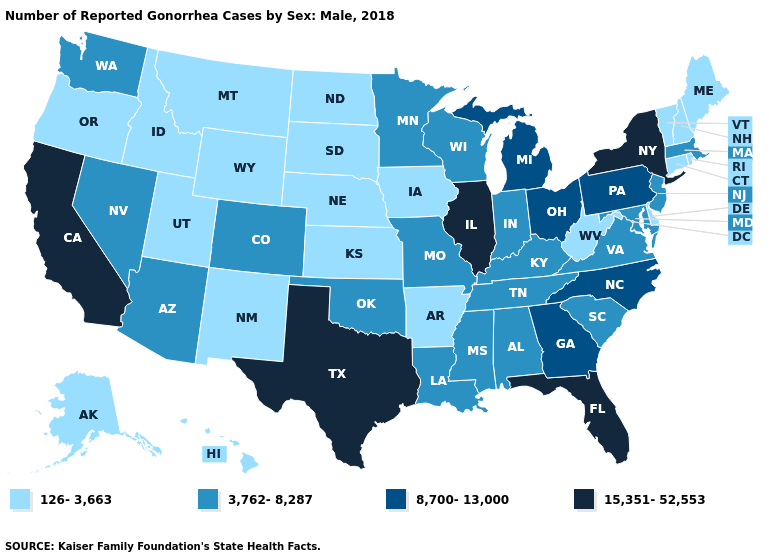Name the states that have a value in the range 15,351-52,553?
Keep it brief. California, Florida, Illinois, New York, Texas. What is the highest value in the USA?
Write a very short answer. 15,351-52,553. Among the states that border Missouri , does Arkansas have the highest value?
Give a very brief answer. No. Among the states that border Iowa , does Wisconsin have the lowest value?
Concise answer only. No. Does Illinois have the lowest value in the USA?
Write a very short answer. No. Which states hav the highest value in the South?
Short answer required. Florida, Texas. What is the value of Arizona?
Quick response, please. 3,762-8,287. Does Massachusetts have the same value as Maryland?
Short answer required. Yes. What is the value of Arizona?
Be succinct. 3,762-8,287. Name the states that have a value in the range 3,762-8,287?
Be succinct. Alabama, Arizona, Colorado, Indiana, Kentucky, Louisiana, Maryland, Massachusetts, Minnesota, Mississippi, Missouri, Nevada, New Jersey, Oklahoma, South Carolina, Tennessee, Virginia, Washington, Wisconsin. What is the value of Texas?
Short answer required. 15,351-52,553. What is the value of Nevada?
Be succinct. 3,762-8,287. Does the first symbol in the legend represent the smallest category?
Keep it brief. Yes. Name the states that have a value in the range 126-3,663?
Keep it brief. Alaska, Arkansas, Connecticut, Delaware, Hawaii, Idaho, Iowa, Kansas, Maine, Montana, Nebraska, New Hampshire, New Mexico, North Dakota, Oregon, Rhode Island, South Dakota, Utah, Vermont, West Virginia, Wyoming. Name the states that have a value in the range 8,700-13,000?
Short answer required. Georgia, Michigan, North Carolina, Ohio, Pennsylvania. 